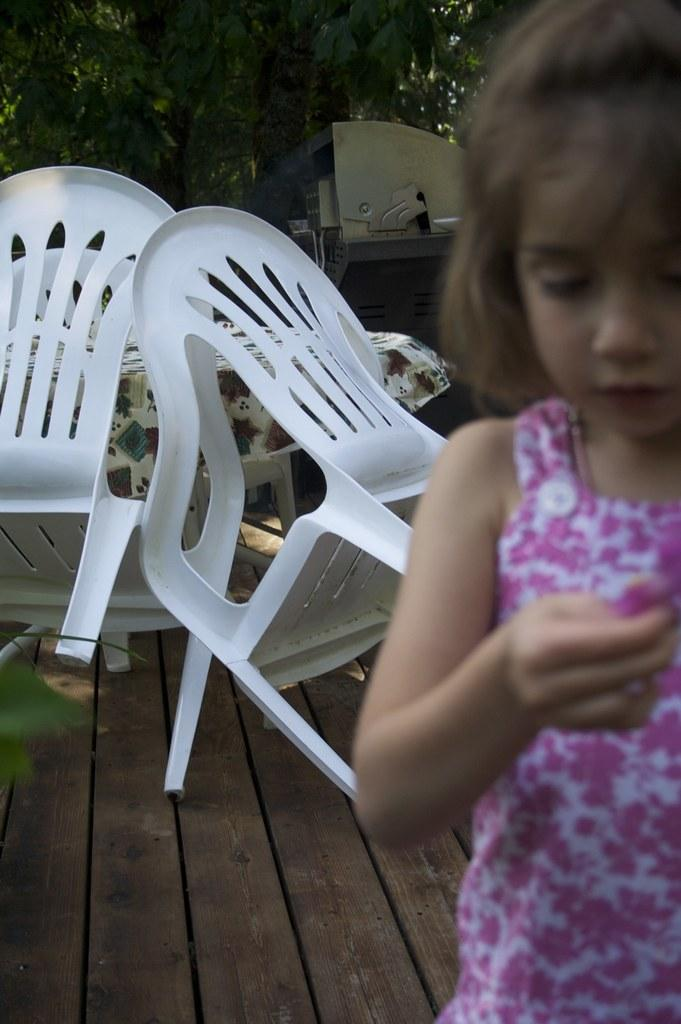Who is the main subject in the image? There is a girl in the image. What furniture is visible in the image? There are chairs and a table in the image. Where are the chairs and table located in relation to the girl? The chairs and table are behind the girl. What type of natural scenery can be seen in the image? There are trees present in the image. What type of vest is the girl wearing in the image? There is no vest visible in the image; the girl is not wearing any clothing mentioned in the facts. 